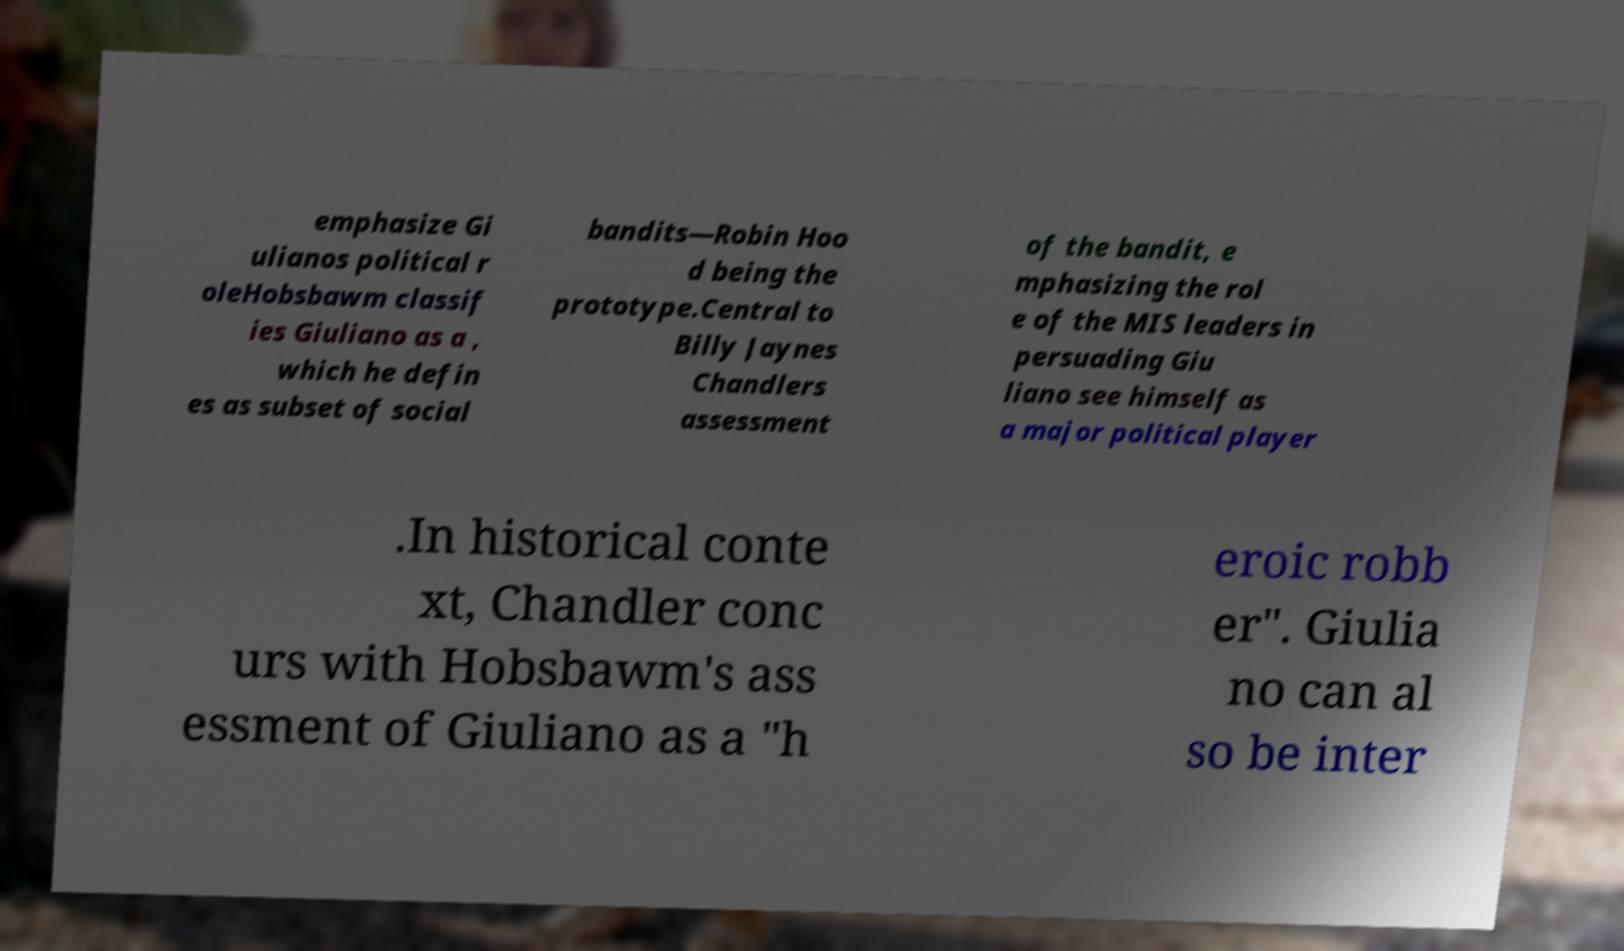I need the written content from this picture converted into text. Can you do that? emphasize Gi ulianos political r oleHobsbawm classif ies Giuliano as a , which he defin es as subset of social bandits—Robin Hoo d being the prototype.Central to Billy Jaynes Chandlers assessment of the bandit, e mphasizing the rol e of the MIS leaders in persuading Giu liano see himself as a major political player .In historical conte xt, Chandler conc urs with Hobsbawm's ass essment of Giuliano as a "h eroic robb er". Giulia no can al so be inter 